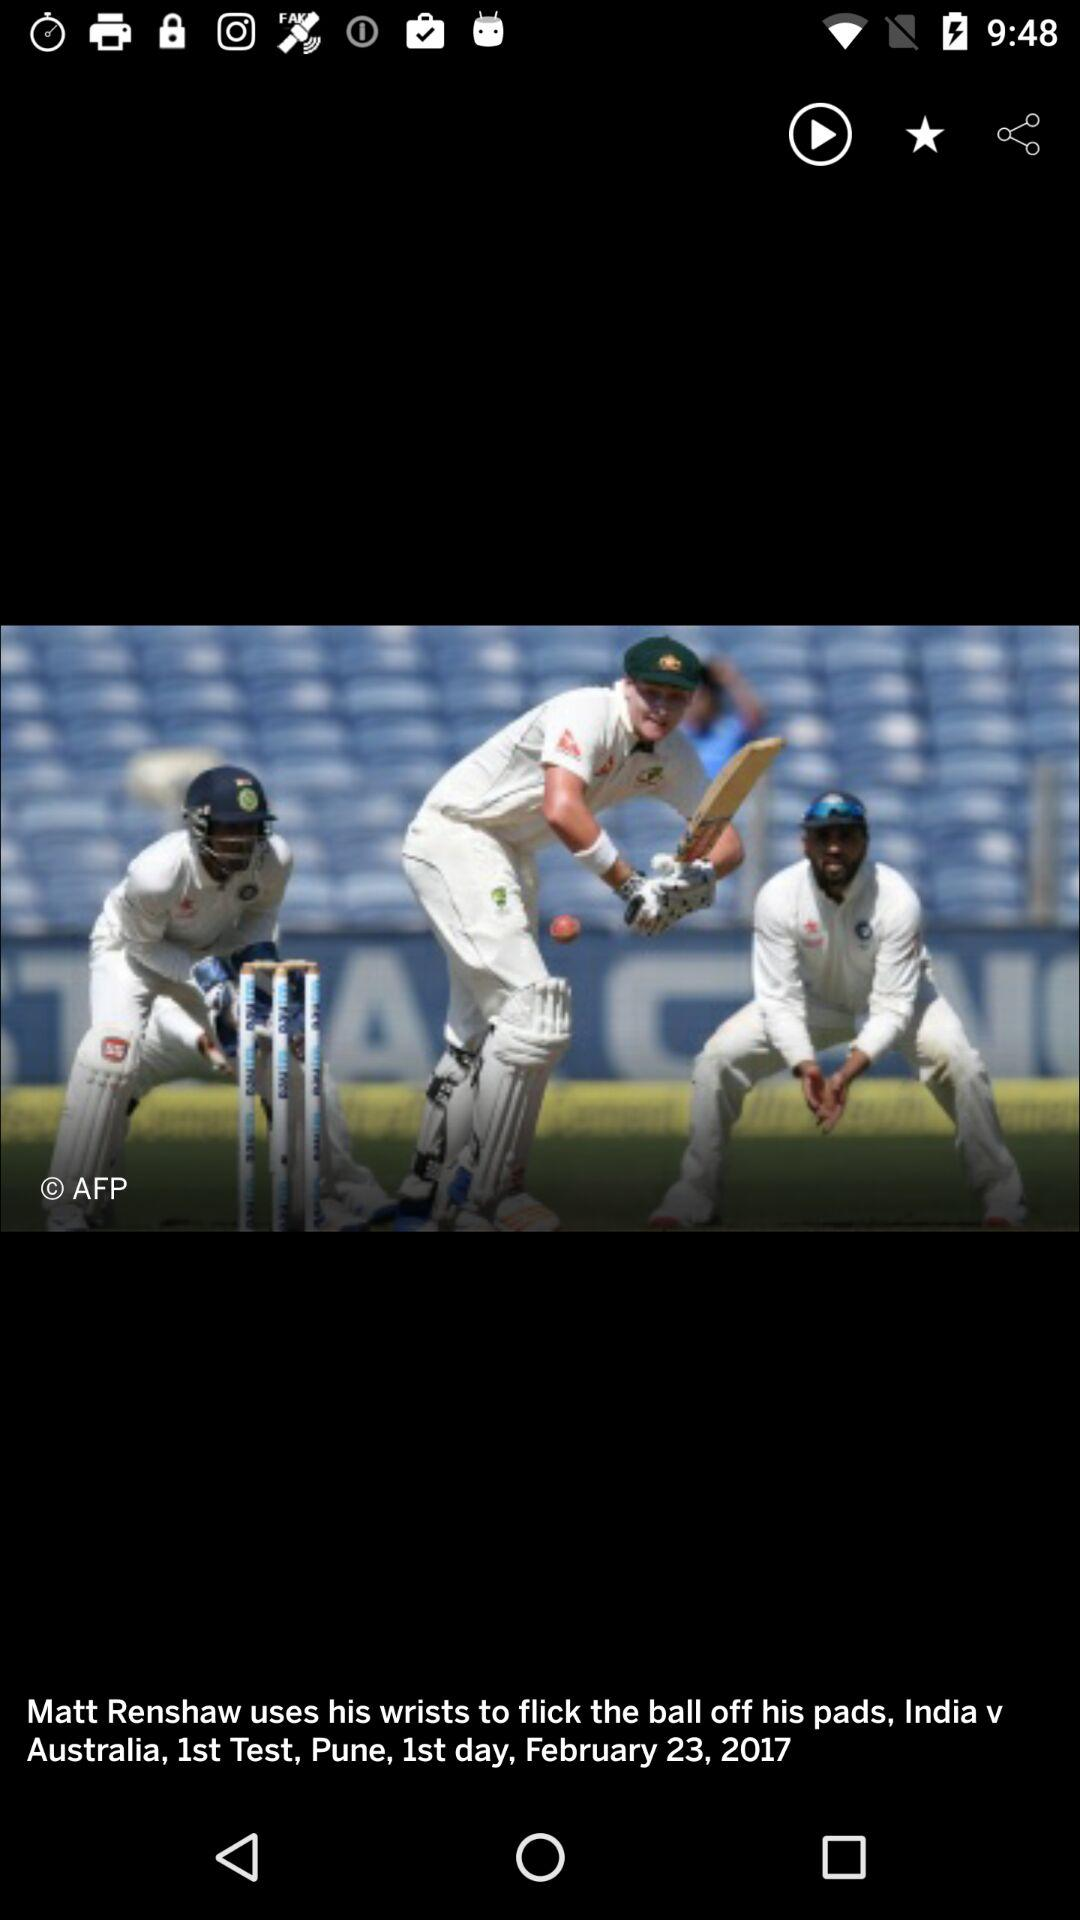What is the venue of the match? The venue of the match is Pune. 